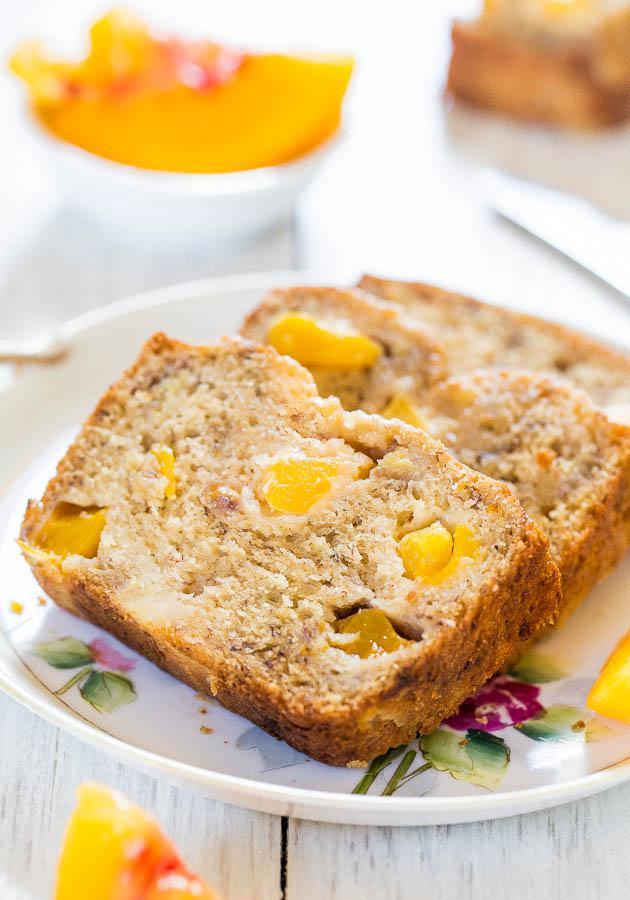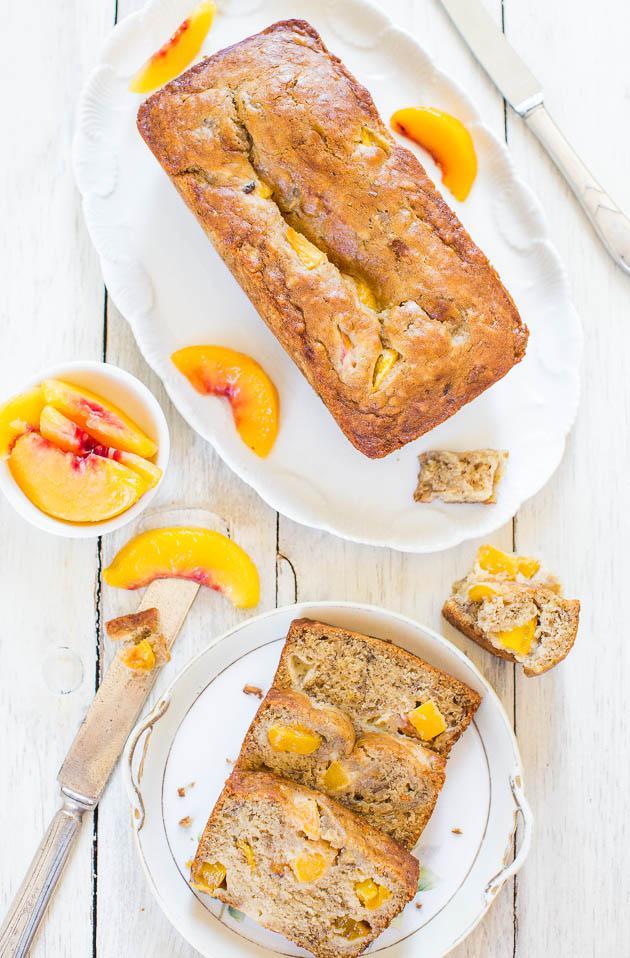The first image is the image on the left, the second image is the image on the right. For the images shown, is this caption "there is a cake with beaches on top and lady finger cookies around the outside" true? Answer yes or no. No. The first image is the image on the left, the second image is the image on the right. Analyze the images presented: Is the assertion "One image shows a plate of sliced desserts in front of an uncut loaf and next to a knife." valid? Answer yes or no. Yes. 